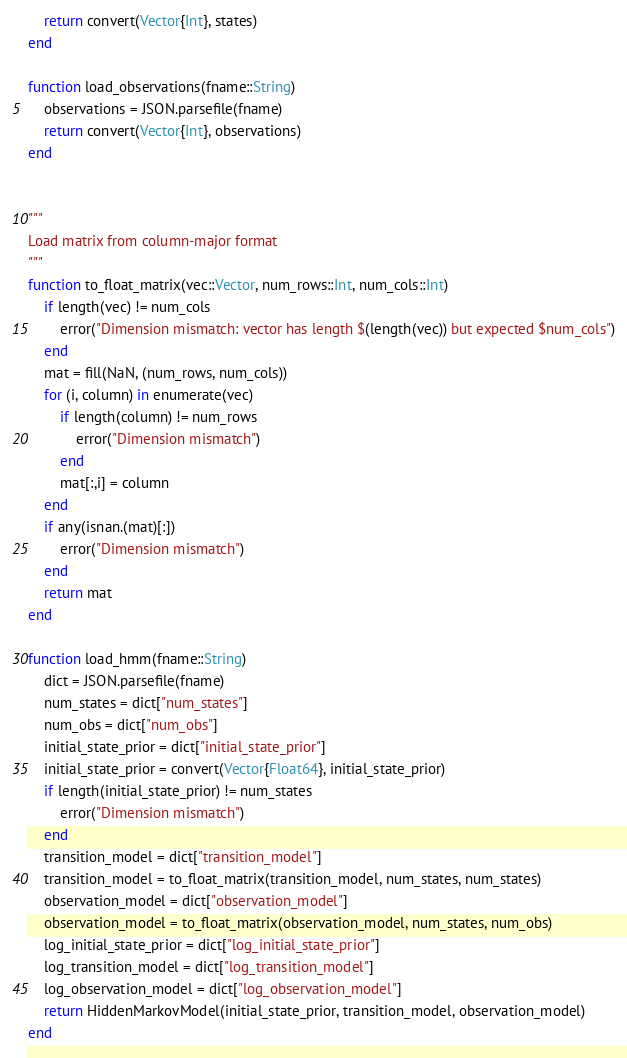Convert code to text. <code><loc_0><loc_0><loc_500><loc_500><_Julia_>    return convert(Vector{Int}, states)
end

function load_observations(fname::String)
    observations = JSON.parsefile(fname)
    return convert(Vector{Int}, observations)
end


"""
Load matrix from column-major format
"""
function to_float_matrix(vec::Vector, num_rows::Int, num_cols::Int)
    if length(vec) != num_cols
        error("Dimension mismatch: vector has length $(length(vec)) but expected $num_cols")
    end
    mat = fill(NaN, (num_rows, num_cols))
    for (i, column) in enumerate(vec)
        if length(column) != num_rows
            error("Dimension mismatch")
        end
        mat[:,i] = column
    end
    if any(isnan.(mat)[:])
        error("Dimension mismatch")
    end
    return mat
end

function load_hmm(fname::String)
    dict = JSON.parsefile(fname)
    num_states = dict["num_states"]
    num_obs = dict["num_obs"]
    initial_state_prior = dict["initial_state_prior"]
    initial_state_prior = convert(Vector{Float64}, initial_state_prior)
    if length(initial_state_prior) != num_states
        error("Dimension mismatch")
    end
    transition_model = dict["transition_model"]
    transition_model = to_float_matrix(transition_model, num_states, num_states)
    observation_model = dict["observation_model"]
    observation_model = to_float_matrix(observation_model, num_states, num_obs)
    log_initial_state_prior = dict["log_initial_state_prior"]
    log_transition_model = dict["log_transition_model"]
    log_observation_model = dict["log_observation_model"]
    return HiddenMarkovModel(initial_state_prior, transition_model, observation_model)
end
</code> 